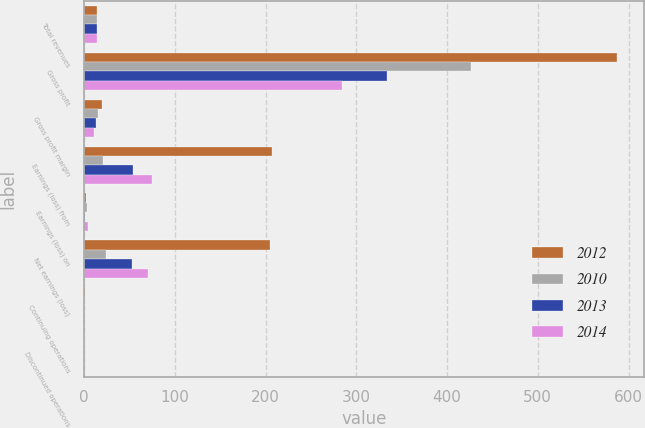Convert chart. <chart><loc_0><loc_0><loc_500><loc_500><stacked_bar_chart><ecel><fcel>Total revenues<fcel>Gross profit<fcel>Gross profit margin<fcel>Earnings (loss) from<fcel>Earnings (loss) on<fcel>Net earnings (loss)<fcel>Continuing operations<fcel>Discontinued operations<nl><fcel>2012<fcel>14.2<fcel>587.6<fcel>19.6<fcel>207.1<fcel>2.2<fcel>204.9<fcel>1.58<fcel>0.02<nl><fcel>2010<fcel>14.2<fcel>426.9<fcel>15.4<fcel>20.8<fcel>3.6<fcel>24.4<fcel>0.16<fcel>0.03<nl><fcel>2013<fcel>14.2<fcel>334<fcel>13<fcel>53.9<fcel>1.3<fcel>52.6<fcel>0.42<fcel>0.01<nl><fcel>2014<fcel>14.2<fcel>283.9<fcel>11.1<fcel>75.3<fcel>4.5<fcel>70.8<fcel>0.58<fcel>0.03<nl></chart> 